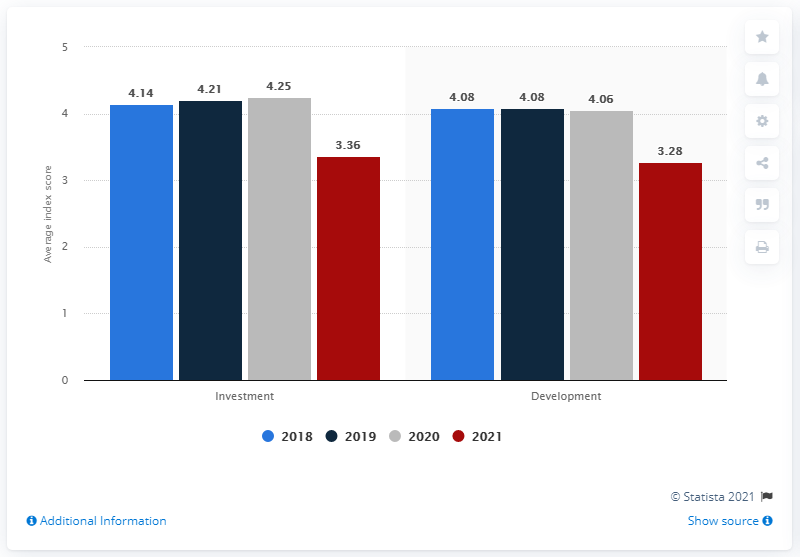Draw attention to some important aspects in this diagram. The average value of development in 2018 and 2019 was 4.08. Red color is associated with the year 2021. 